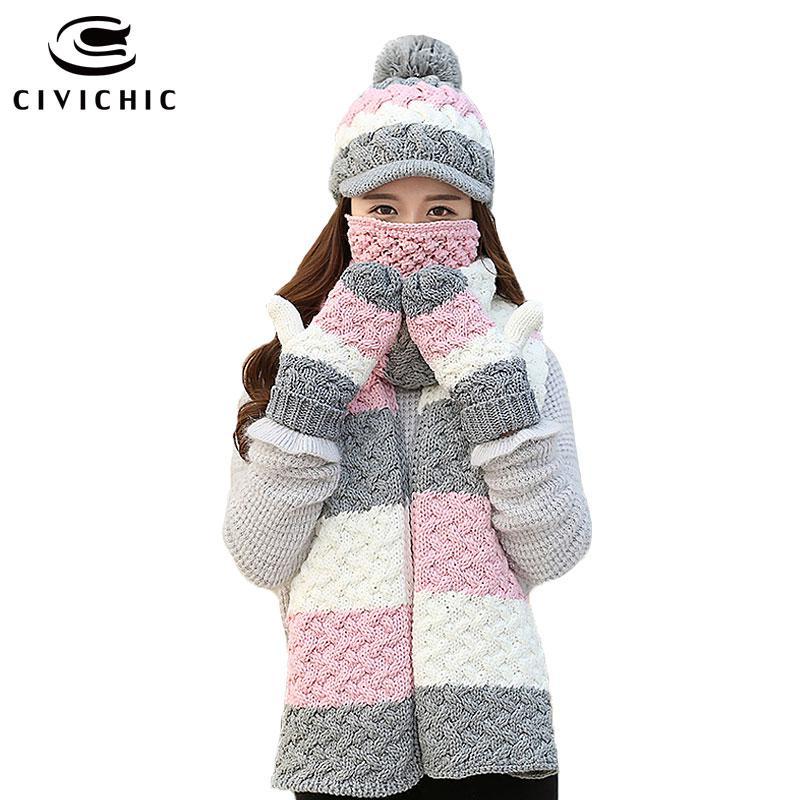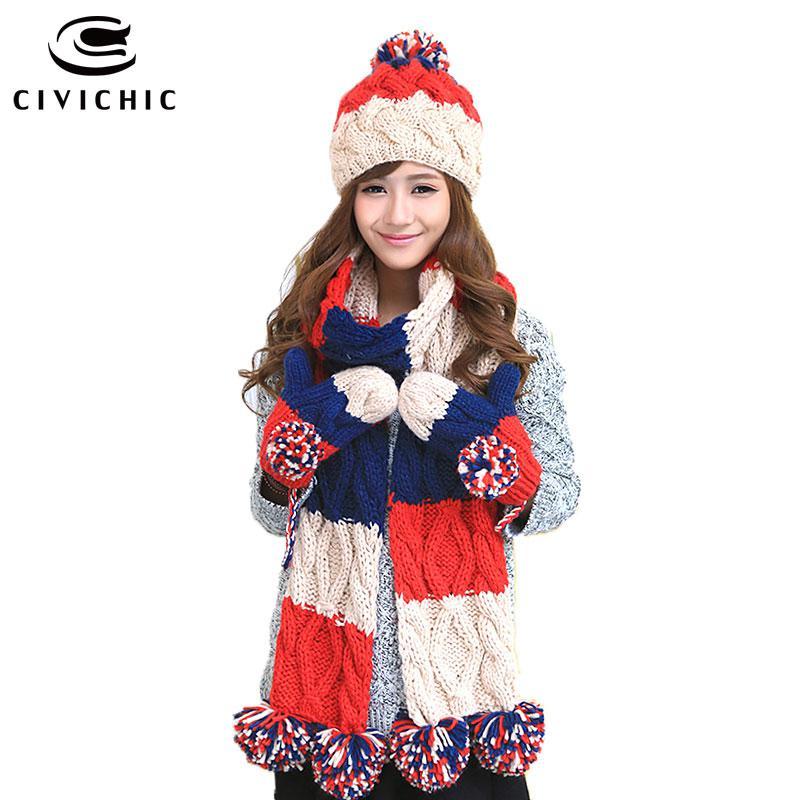The first image is the image on the left, the second image is the image on the right. Analyze the images presented: Is the assertion "there is a girl with a scarf covering the bottom half of her face" valid? Answer yes or no. Yes. The first image is the image on the left, the second image is the image on the right. For the images displayed, is the sentence "A young girl is wearing a matching scarf, hat and gloves set that is white, brown and pink." factually correct? Answer yes or no. No. 